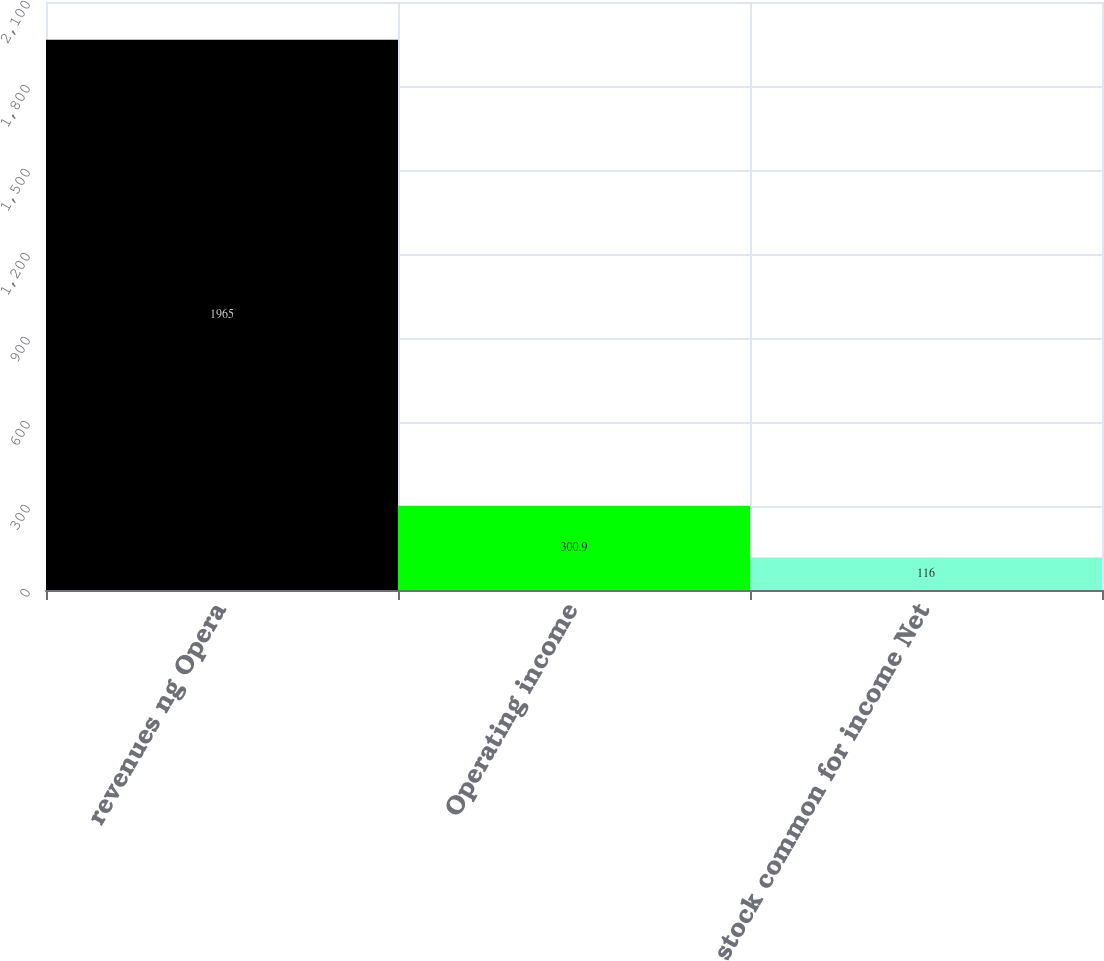Convert chart to OTSL. <chart><loc_0><loc_0><loc_500><loc_500><bar_chart><fcel>revenues ng Opera<fcel>Operating income<fcel>stock common for income Net<nl><fcel>1965<fcel>300.9<fcel>116<nl></chart> 